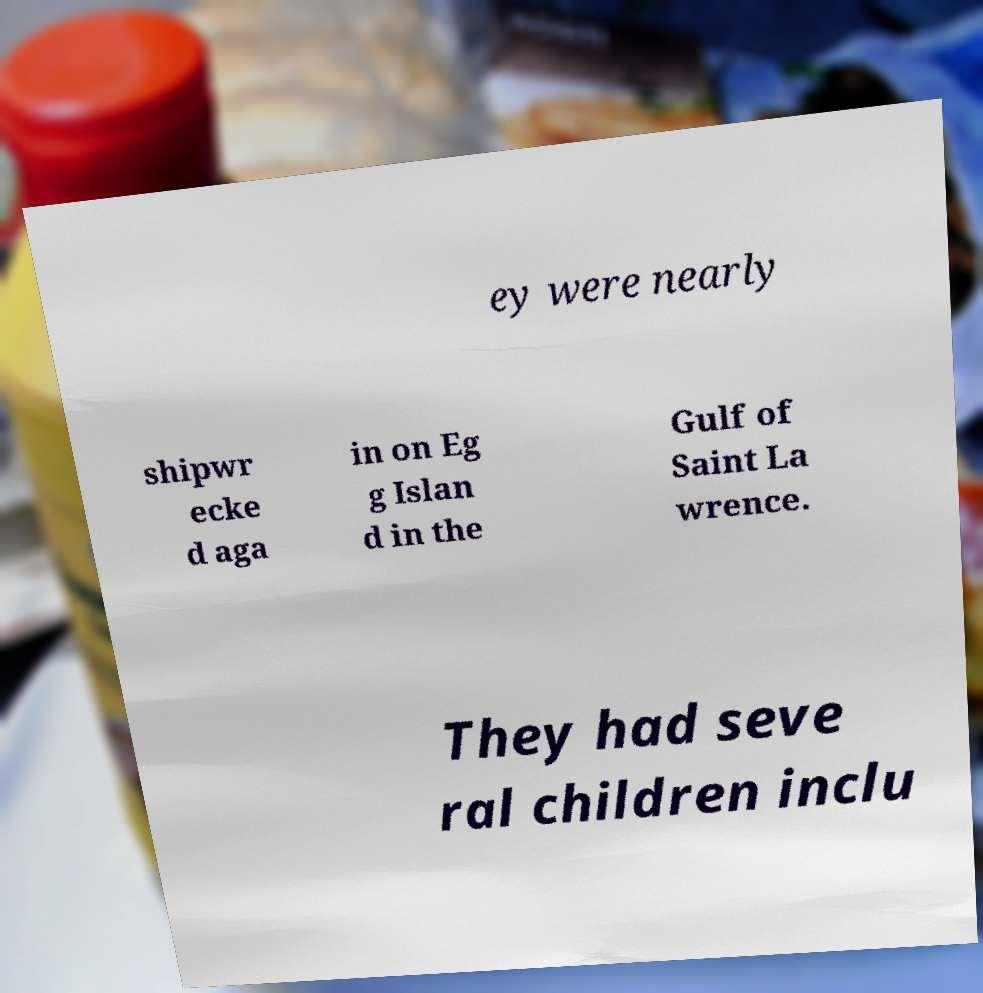Can you read and provide the text displayed in the image?This photo seems to have some interesting text. Can you extract and type it out for me? ey were nearly shipwr ecke d aga in on Eg g Islan d in the Gulf of Saint La wrence. They had seve ral children inclu 